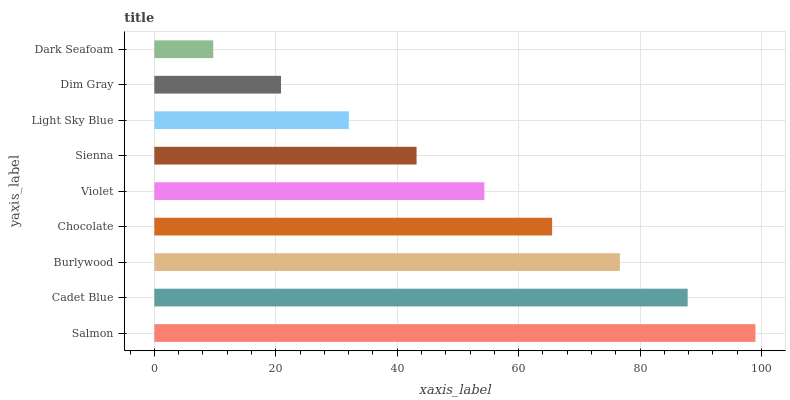Is Dark Seafoam the minimum?
Answer yes or no. Yes. Is Salmon the maximum?
Answer yes or no. Yes. Is Cadet Blue the minimum?
Answer yes or no. No. Is Cadet Blue the maximum?
Answer yes or no. No. Is Salmon greater than Cadet Blue?
Answer yes or no. Yes. Is Cadet Blue less than Salmon?
Answer yes or no. Yes. Is Cadet Blue greater than Salmon?
Answer yes or no. No. Is Salmon less than Cadet Blue?
Answer yes or no. No. Is Violet the high median?
Answer yes or no. Yes. Is Violet the low median?
Answer yes or no. Yes. Is Dim Gray the high median?
Answer yes or no. No. Is Sienna the low median?
Answer yes or no. No. 